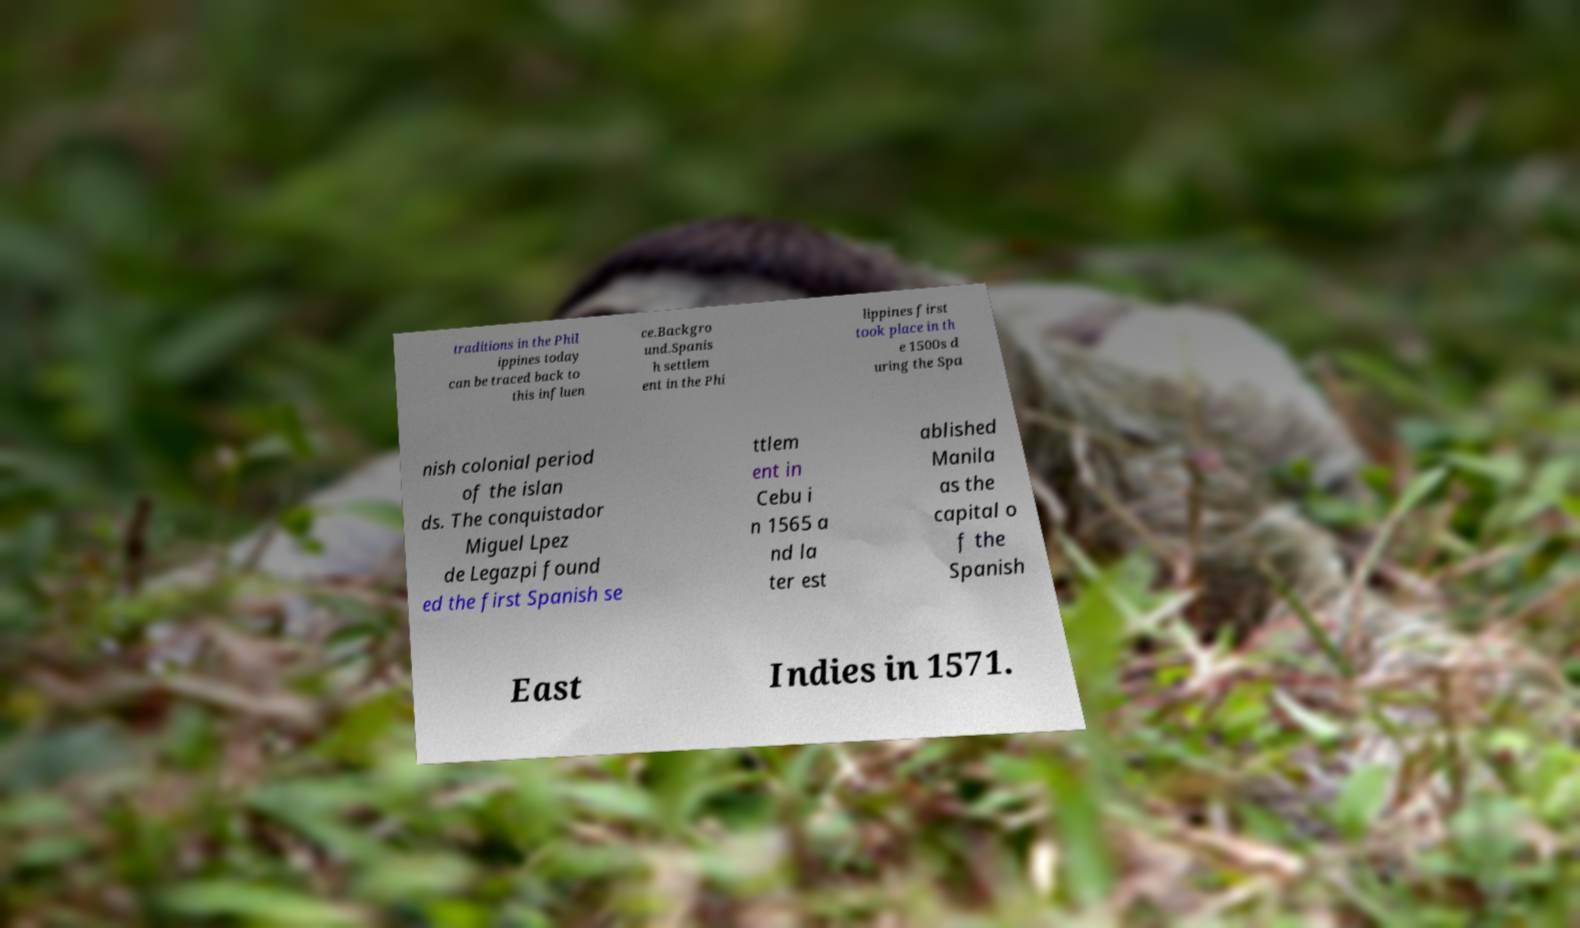Please identify and transcribe the text found in this image. traditions in the Phil ippines today can be traced back to this influen ce.Backgro und.Spanis h settlem ent in the Phi lippines first took place in th e 1500s d uring the Spa nish colonial period of the islan ds. The conquistador Miguel Lpez de Legazpi found ed the first Spanish se ttlem ent in Cebu i n 1565 a nd la ter est ablished Manila as the capital o f the Spanish East Indies in 1571. 